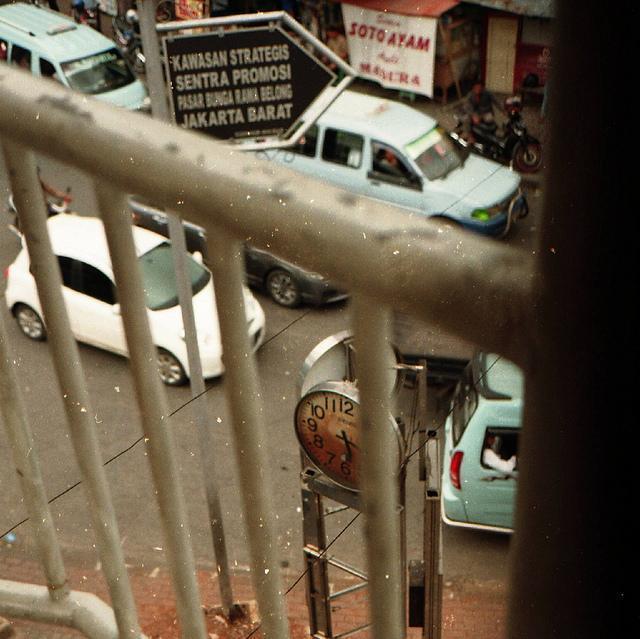How many cars can be seen?
Give a very brief answer. 5. How many skateboards are in the picture?
Give a very brief answer. 0. 